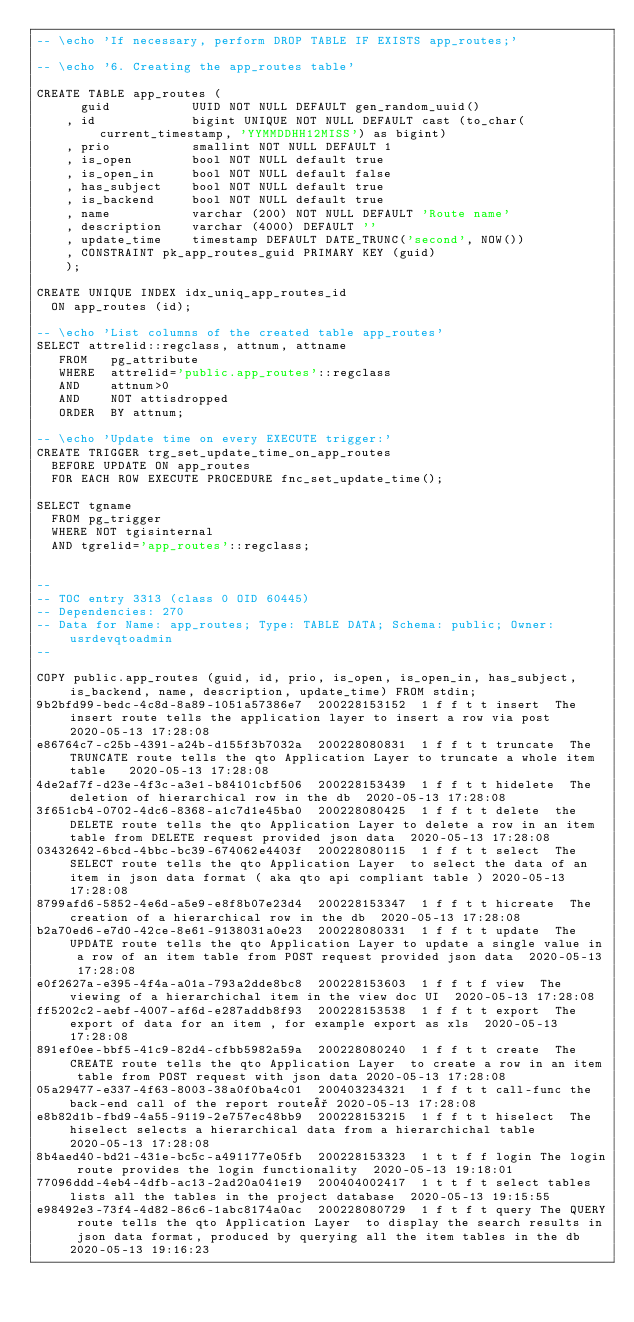<code> <loc_0><loc_0><loc_500><loc_500><_SQL_>-- \echo 'If necessary, perform DROP TABLE IF EXISTS app_routes;'

-- \echo '6. Creating the app_routes table'

CREATE TABLE app_routes (
      guid           UUID NOT NULL DEFAULT gen_random_uuid()
    , id             bigint UNIQUE NOT NULL DEFAULT cast (to_char(current_timestamp, 'YYMMDDHH12MISS') as bigint) 
    , prio           smallint NOT NULL DEFAULT 1
    , is_open        bool NOT NULL default true
    , is_open_in     bool NOT NULL default false
    , has_subject    bool NOT NULL default true
    , is_backend     bool NOT NULL default true
    , name           varchar (200) NOT NULL DEFAULT 'Route name'
    , description    varchar (4000) DEFAULT ''
    , update_time    timestamp DEFAULT DATE_TRUNC('second', NOW())
    , CONSTRAINT pk_app_routes_guid PRIMARY KEY (guid)
    );

CREATE UNIQUE INDEX idx_uniq_app_routes_id
	ON app_routes (id);

-- \echo 'List columns of the created table app_routes'
SELECT attrelid::regclass, attnum, attname
   FROM   pg_attribute
   WHERE  attrelid='public.app_routes'::regclass
   AND    attnum>0
   AND    NOT attisdropped
   ORDER  BY attnum; 

-- \echo 'Update time on every EXECUTE trigger:'
CREATE TRIGGER trg_set_update_time_on_app_routes
	BEFORE UPDATE ON app_routes
	FOR EACH ROW EXECUTE PROCEDURE fnc_set_update_time();

SELECT tgname
	FROM pg_trigger
	WHERE NOT tgisinternal
	AND tgrelid='app_routes'::regclass;


--
-- TOC entry 3313 (class 0 OID 60445)
-- Dependencies: 270
-- Data for Name: app_routes; Type: TABLE DATA; Schema: public; Owner: usrdevqtoadmin
--

COPY public.app_routes (guid, id, prio, is_open, is_open_in, has_subject, is_backend, name, description, update_time) FROM stdin;
9b2bfd99-bedc-4c8d-8a89-1051a57386e7	200228153152	1	f	f	t	t	insert	The insert route tells the application layer to insert a row via post 	2020-05-13 17:28:08
e86764c7-c25b-4391-a24b-d155f3b7032a	200228080831	1	f	f	t	t	truncate	The TRUNCATE route tells the qto Application Layer to truncate a whole item table 	2020-05-13 17:28:08
4de2af7f-d23e-4f3c-a3e1-b84101cbf506	200228153439	1	f	f	t	t	hidelete	The deletion of hierarchical row in the db	2020-05-13 17:28:08
3f651cb4-0702-4dc6-8368-a1c7d1e45ba0	200228080425	1	f	f	t	t	delete	the DELETE route tells the qto Application Layer to delete a row in an item table from DELETE request provided json data	2020-05-13 17:28:08
03432642-6bcd-4bbc-bc39-674062e4403f	200228080115	1	f	f	t	t	select	The SELECT route tells the qto Application Layer  to select the data of an item in json data format ( aka qto api compliant table )	2020-05-13 17:28:08
8799afd6-5852-4e6d-a5e9-e8f8b07e23d4	200228153347	1	f	f	t	t	hicreate	The creation of a hierarchical row in the db	2020-05-13 17:28:08
b2a70ed6-e7d0-42ce-8e61-9138031a0e23	200228080331	1	f	f	t	t	update	The UPDATE route tells the qto Application Layer to update a single value in a row of an item table from POST request provided json data	2020-05-13 17:28:08
e0f2627a-e395-4f4a-a01a-793a2dde8bc8	200228153603	1	f	f	t	f	view	The viewing of a hierarchichal item in the view doc UI 	2020-05-13 17:28:08
ff5202c2-aebf-4007-af6d-e287addb8f93	200228153538	1	f	f	t	t	export	The export of data for an item , for example export as xls	2020-05-13 17:28:08
891ef0ee-bbf5-41c9-82d4-cfbb5982a59a	200228080240	1	f	f	t	t	create	The CREATE route tells the qto Application Layer  to create a row in an item table from POST request with json data	2020-05-13 17:28:08
05a29477-e337-4f63-8003-38a0f0ba4c01	200403234321	1	f	f	t	t	call-func	the back-end call of the report route°	2020-05-13 17:28:08
e8b82d1b-fbd9-4a55-9119-2e757ec48bb9	200228153215	1	f	f	t	t	hiselect	The hiselect selects a hierarchical data from a hierarchichal table	2020-05-13 17:28:08
8b4aed40-bd21-431e-bc5c-a491177e05fb	200228153323	1	t	t	f	f	login	The login route provides the login functionality	2020-05-13 19:18:01
77096ddd-4eb4-4dfb-ac13-2ad20a041e19	200404002417	1	t	t	f	t	select tables	lists all the tables in the project database	2020-05-13 19:15:55
e98492e3-73f4-4d82-86c6-1abc8174a0ac	200228080729	1	f	t	f	t	query	The QUERY route tells the qto Application Layer  to display the search results in json data format, produced by querying all the item tables in the db	2020-05-13 19:16:23</code> 